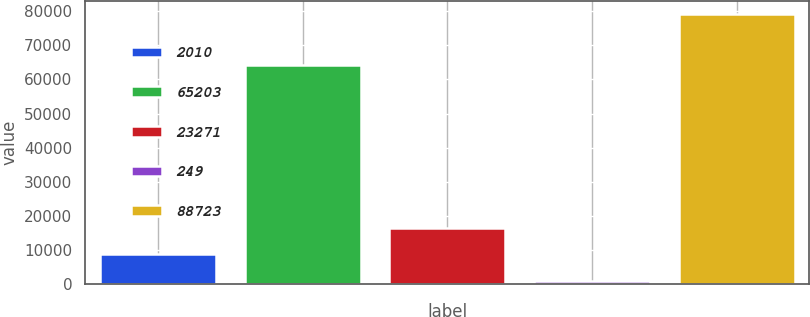<chart> <loc_0><loc_0><loc_500><loc_500><bar_chart><fcel>2010<fcel>65203<fcel>23271<fcel>249<fcel>88723<nl><fcel>8740.6<fcel>64281<fcel>16553.2<fcel>928<fcel>79054<nl></chart> 